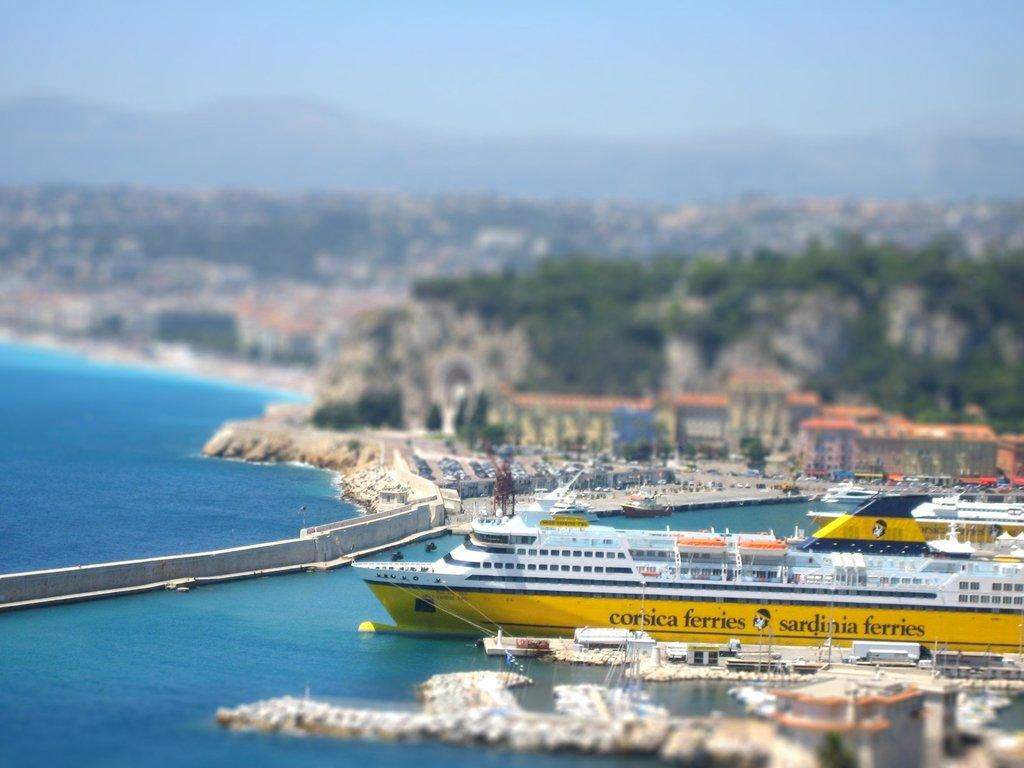What type of structures can be seen in the image? There are buildings in the image. What vehicles are present in the image? There are boats in the image. What type of vegetation is visible in the image? There are trees in the image. What architectural feature connects the two sides of the water? There is a bridge in the image. What natural element is present in the image? There is water in the image. What colors can be seen in the sky in the image? The sky is white and blue in color. How many bricks are used to build the drop in the image? There is no drop present in the image, and therefore no bricks are used to build it. Can you see any frogs swimming in the water in the image? There are no frogs visible in the image; it features boats and a bridge. 